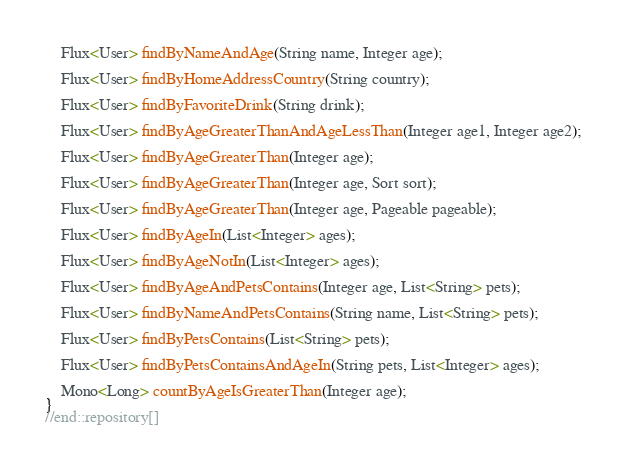<code> <loc_0><loc_0><loc_500><loc_500><_Java_>	Flux<User> findByNameAndAge(String name, Integer age);

	Flux<User> findByHomeAddressCountry(String country);

	Flux<User> findByFavoriteDrink(String drink);

	Flux<User> findByAgeGreaterThanAndAgeLessThan(Integer age1, Integer age2);

	Flux<User> findByAgeGreaterThan(Integer age);

	Flux<User> findByAgeGreaterThan(Integer age, Sort sort);

	Flux<User> findByAgeGreaterThan(Integer age, Pageable pageable);

	Flux<User> findByAgeIn(List<Integer> ages);

	Flux<User> findByAgeNotIn(List<Integer> ages);

	Flux<User> findByAgeAndPetsContains(Integer age, List<String> pets);

	Flux<User> findByNameAndPetsContains(String name, List<String> pets);

	Flux<User> findByPetsContains(List<String> pets);

	Flux<User> findByPetsContainsAndAgeIn(String pets, List<Integer> ages);

	Mono<Long> countByAgeIsGreaterThan(Integer age);
}
//end::repository[]
</code> 